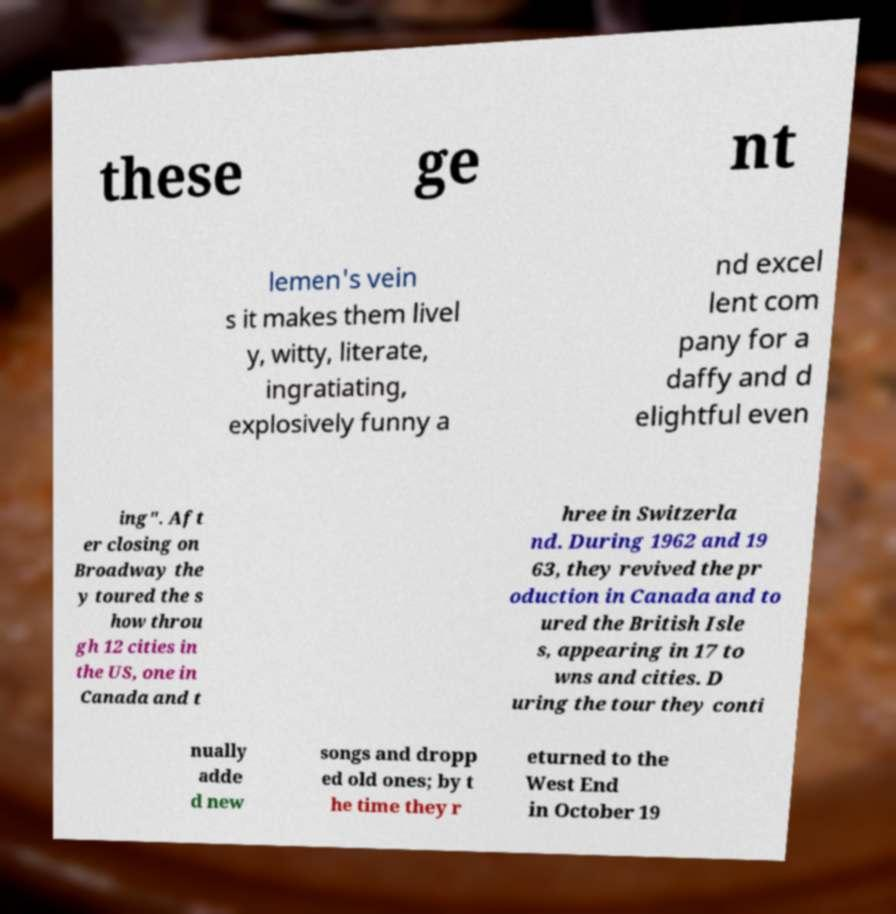Can you accurately transcribe the text from the provided image for me? these ge nt lemen's vein s it makes them livel y, witty, literate, ingratiating, explosively funny a nd excel lent com pany for a daffy and d elightful even ing". Aft er closing on Broadway the y toured the s how throu gh 12 cities in the US, one in Canada and t hree in Switzerla nd. During 1962 and 19 63, they revived the pr oduction in Canada and to ured the British Isle s, appearing in 17 to wns and cities. D uring the tour they conti nually adde d new songs and dropp ed old ones; by t he time they r eturned to the West End in October 19 